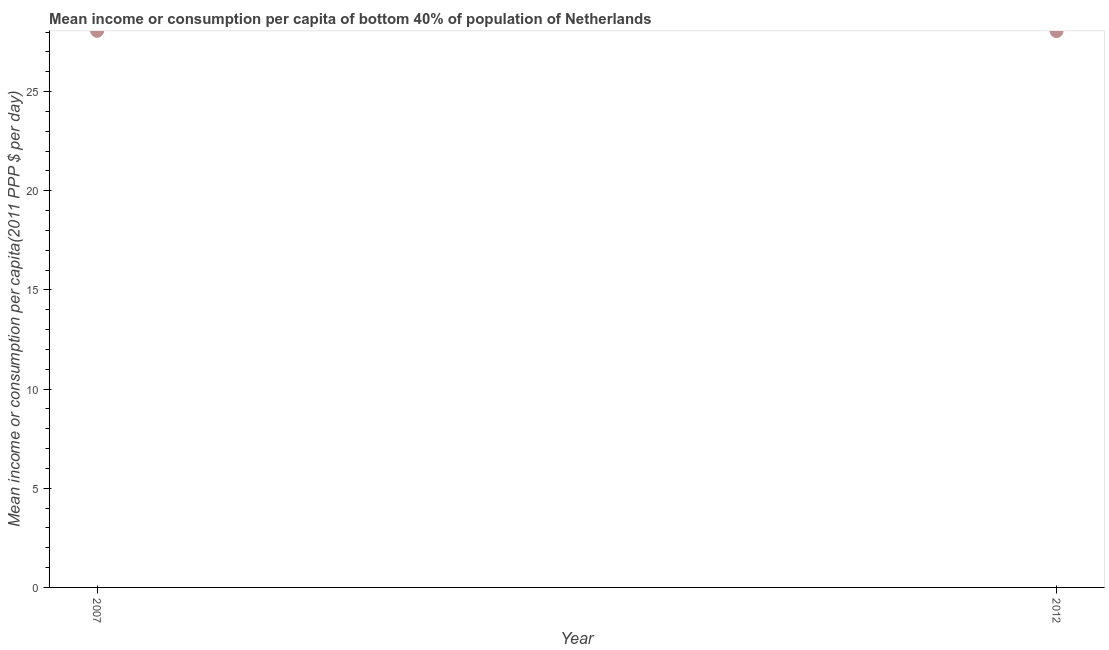What is the mean income or consumption in 2012?
Give a very brief answer. 28.05. Across all years, what is the maximum mean income or consumption?
Offer a terse response. 28.06. Across all years, what is the minimum mean income or consumption?
Ensure brevity in your answer.  28.05. What is the sum of the mean income or consumption?
Provide a succinct answer. 56.11. What is the difference between the mean income or consumption in 2007 and 2012?
Offer a terse response. 0.01. What is the average mean income or consumption per year?
Give a very brief answer. 28.06. What is the median mean income or consumption?
Your answer should be compact. 28.06. In how many years, is the mean income or consumption greater than 15 $?
Keep it short and to the point. 2. Do a majority of the years between 2007 and 2012 (inclusive) have mean income or consumption greater than 4 $?
Ensure brevity in your answer.  Yes. What is the ratio of the mean income or consumption in 2007 to that in 2012?
Provide a succinct answer. 1. In how many years, is the mean income or consumption greater than the average mean income or consumption taken over all years?
Your response must be concise. 1. How many dotlines are there?
Your response must be concise. 1. What is the difference between two consecutive major ticks on the Y-axis?
Your response must be concise. 5. Are the values on the major ticks of Y-axis written in scientific E-notation?
Provide a short and direct response. No. Does the graph contain any zero values?
Provide a succinct answer. No. What is the title of the graph?
Your answer should be very brief. Mean income or consumption per capita of bottom 40% of population of Netherlands. What is the label or title of the X-axis?
Offer a very short reply. Year. What is the label or title of the Y-axis?
Your answer should be compact. Mean income or consumption per capita(2011 PPP $ per day). What is the Mean income or consumption per capita(2011 PPP $ per day) in 2007?
Offer a terse response. 28.06. What is the Mean income or consumption per capita(2011 PPP $ per day) in 2012?
Provide a succinct answer. 28.05. What is the difference between the Mean income or consumption per capita(2011 PPP $ per day) in 2007 and 2012?
Provide a short and direct response. 0.01. 